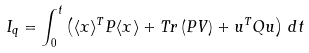Convert formula to latex. <formula><loc_0><loc_0><loc_500><loc_500>I _ { q } = \int _ { 0 } ^ { t } \left ( \langle { x } \rangle ^ { T } P \langle { x } \rangle + T r \left ( P V \right ) + { u } ^ { T } Q { u } \right ) \, d t</formula> 